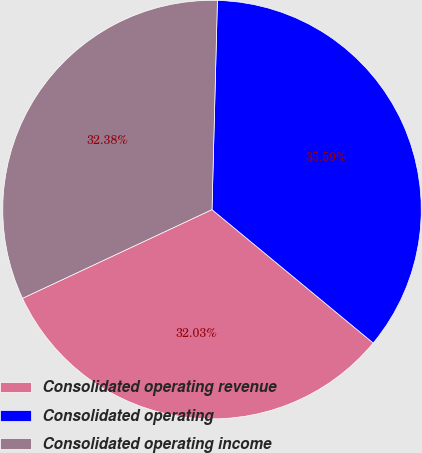<chart> <loc_0><loc_0><loc_500><loc_500><pie_chart><fcel>Consolidated operating revenue<fcel>Consolidated operating<fcel>Consolidated operating income<nl><fcel>32.03%<fcel>35.59%<fcel>32.38%<nl></chart> 